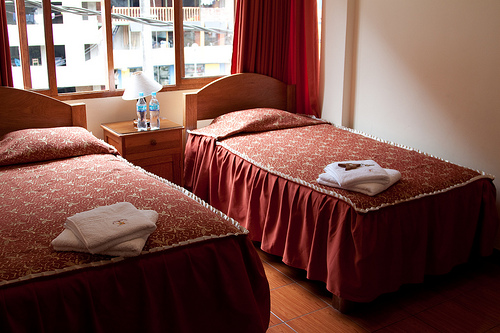What might be the view from the window in this room? The view from the window likely features an urban landscape, with nearby residential buildings. It provides a glimpse into the bustling city life, typical for hotels located in densely populated areas. 